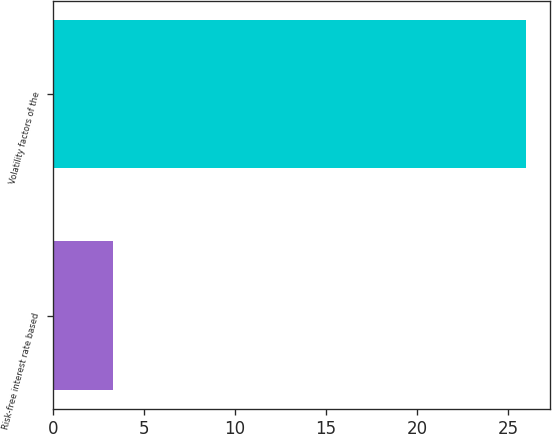Convert chart to OTSL. <chart><loc_0><loc_0><loc_500><loc_500><bar_chart><fcel>Risk-free interest rate based<fcel>Volatility factors of the<nl><fcel>3.29<fcel>26<nl></chart> 